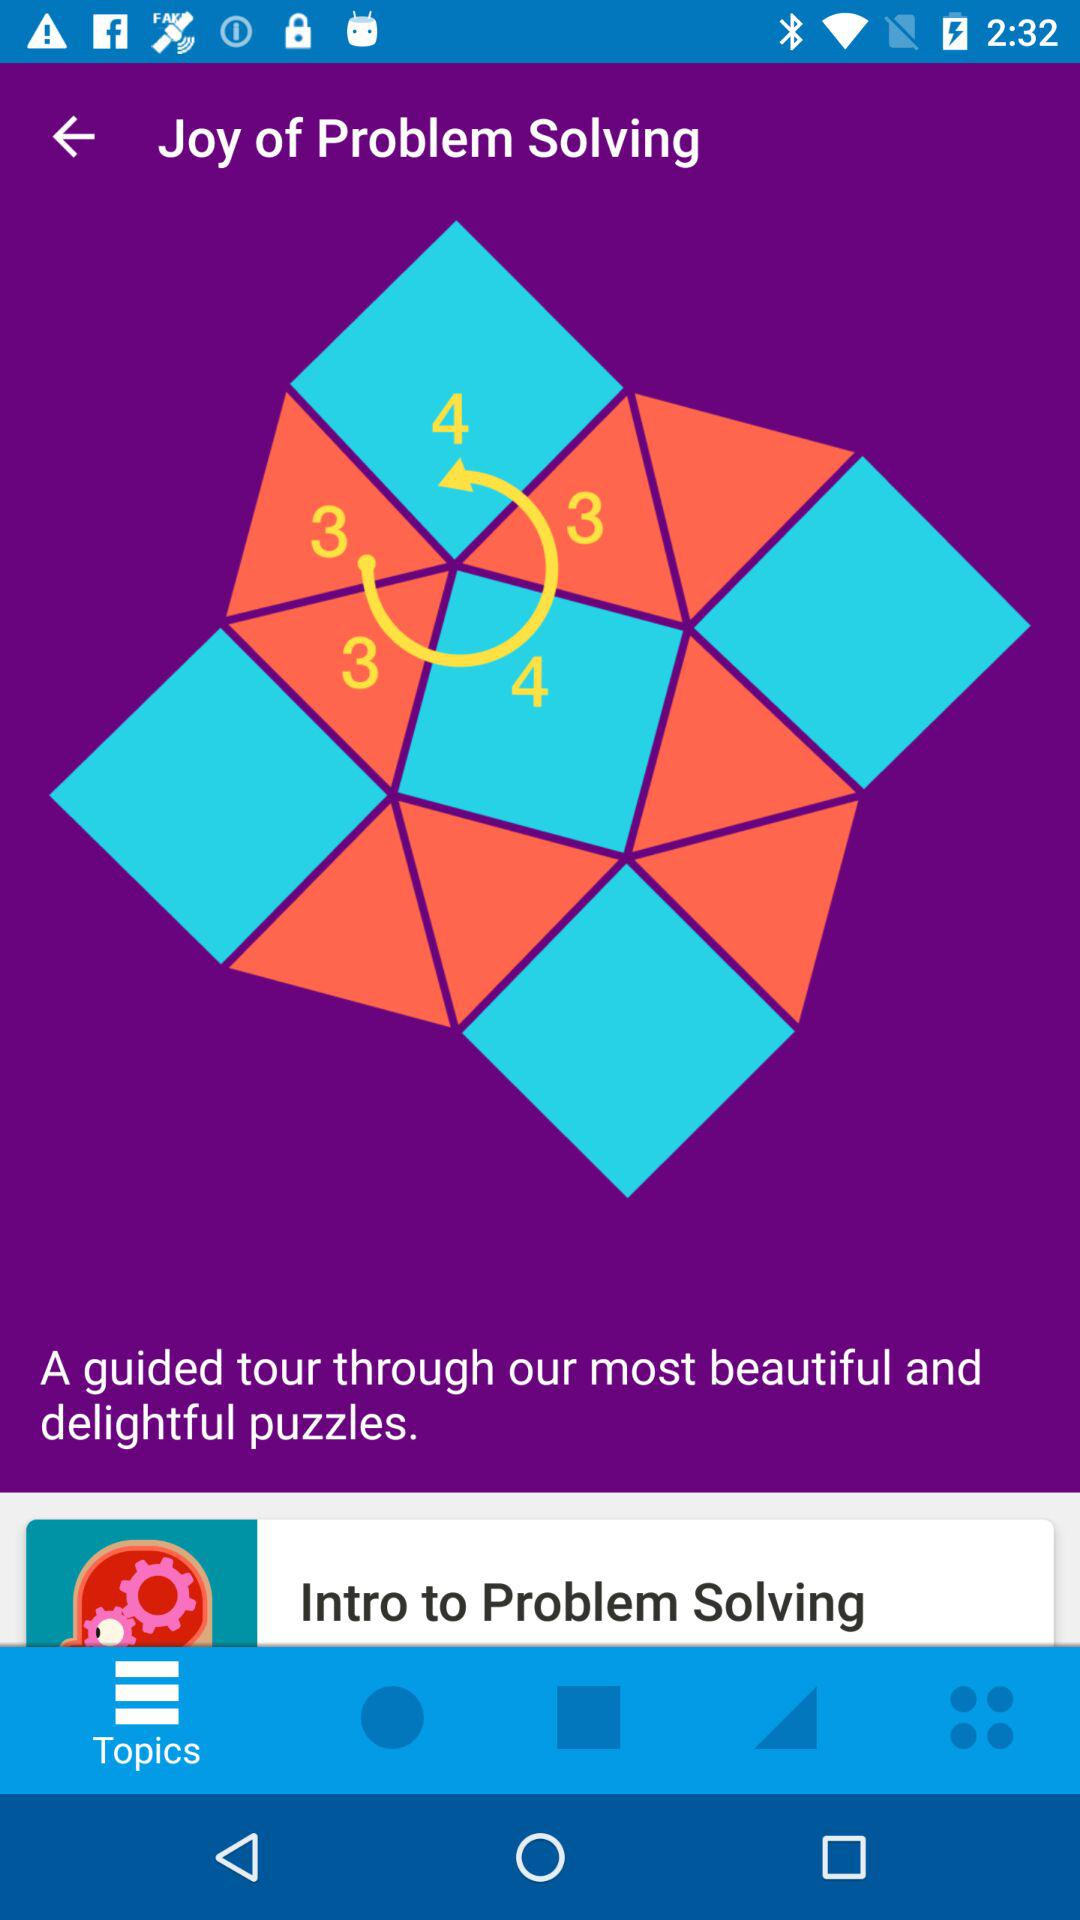What is the course name? The course name is "Joy of Problem Solving". 